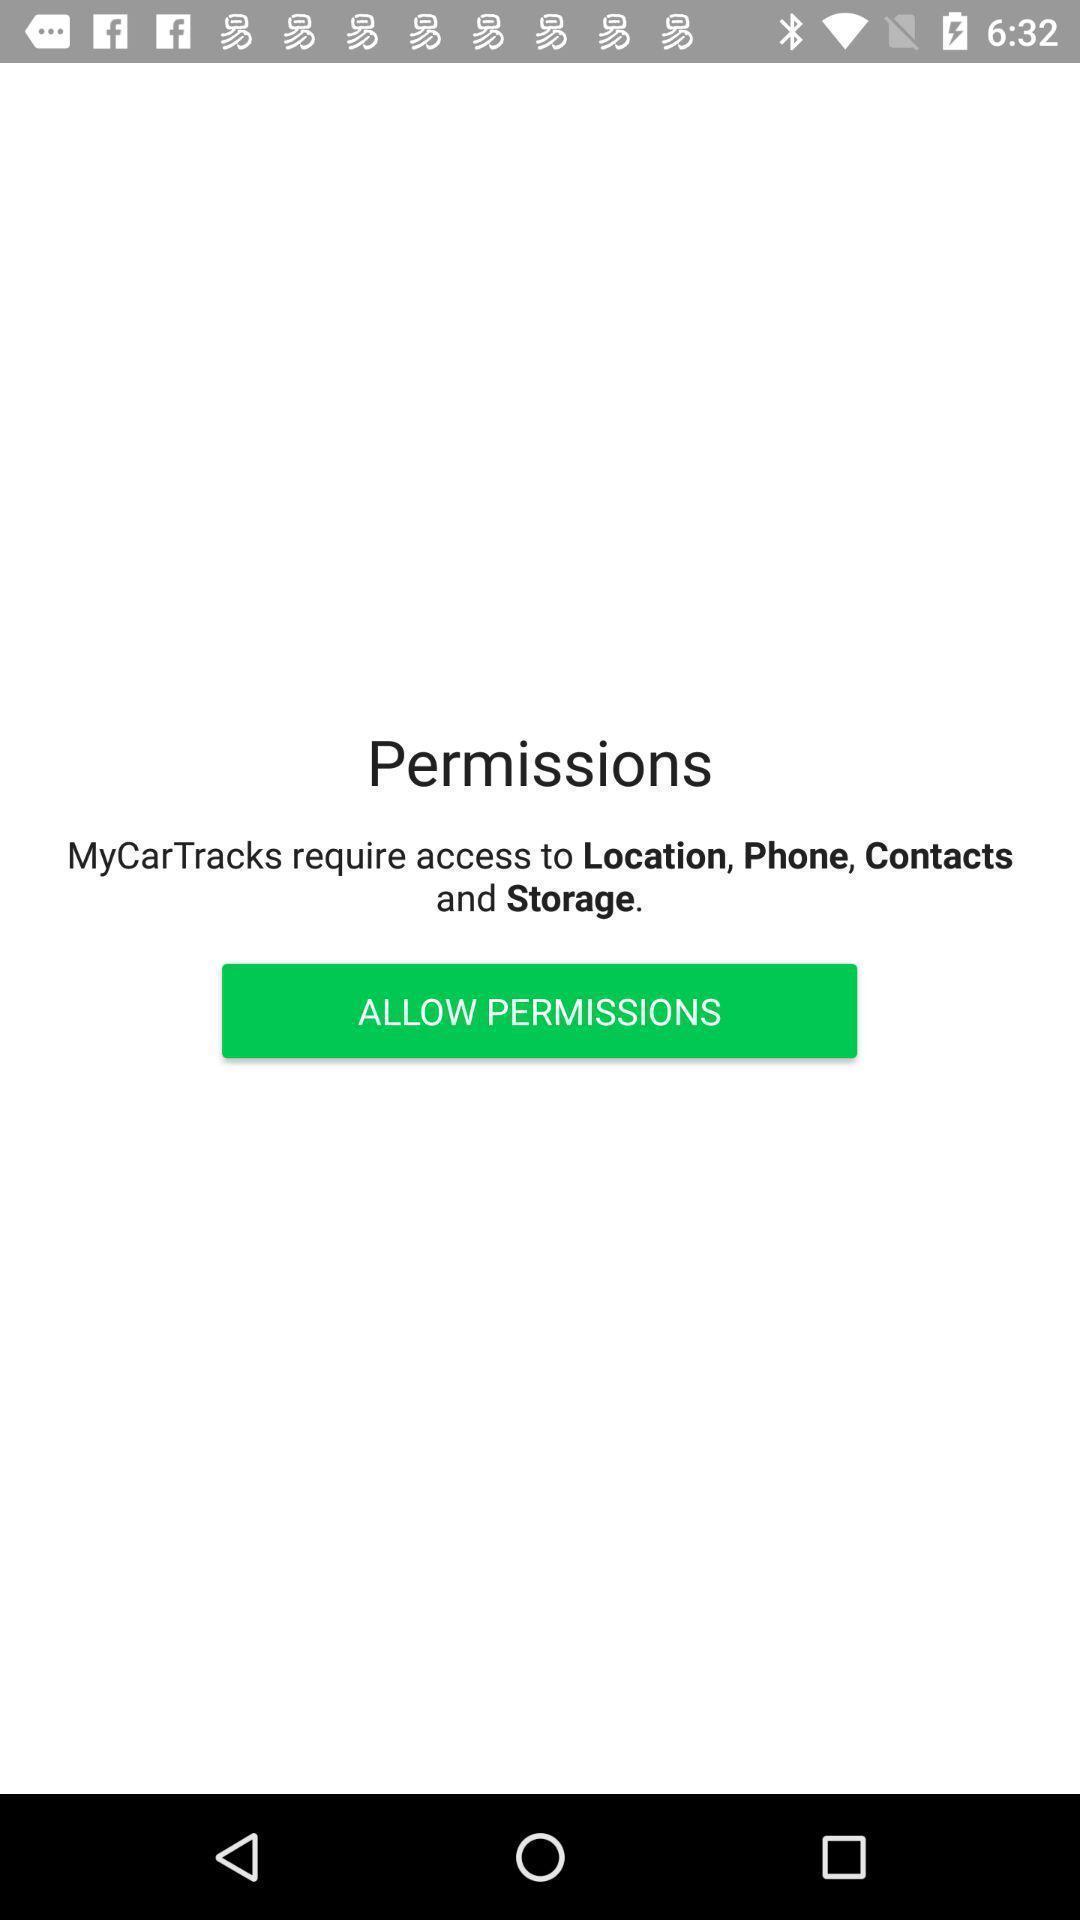Explain what's happening in this screen capture. Screen displaying to allow permissions. 